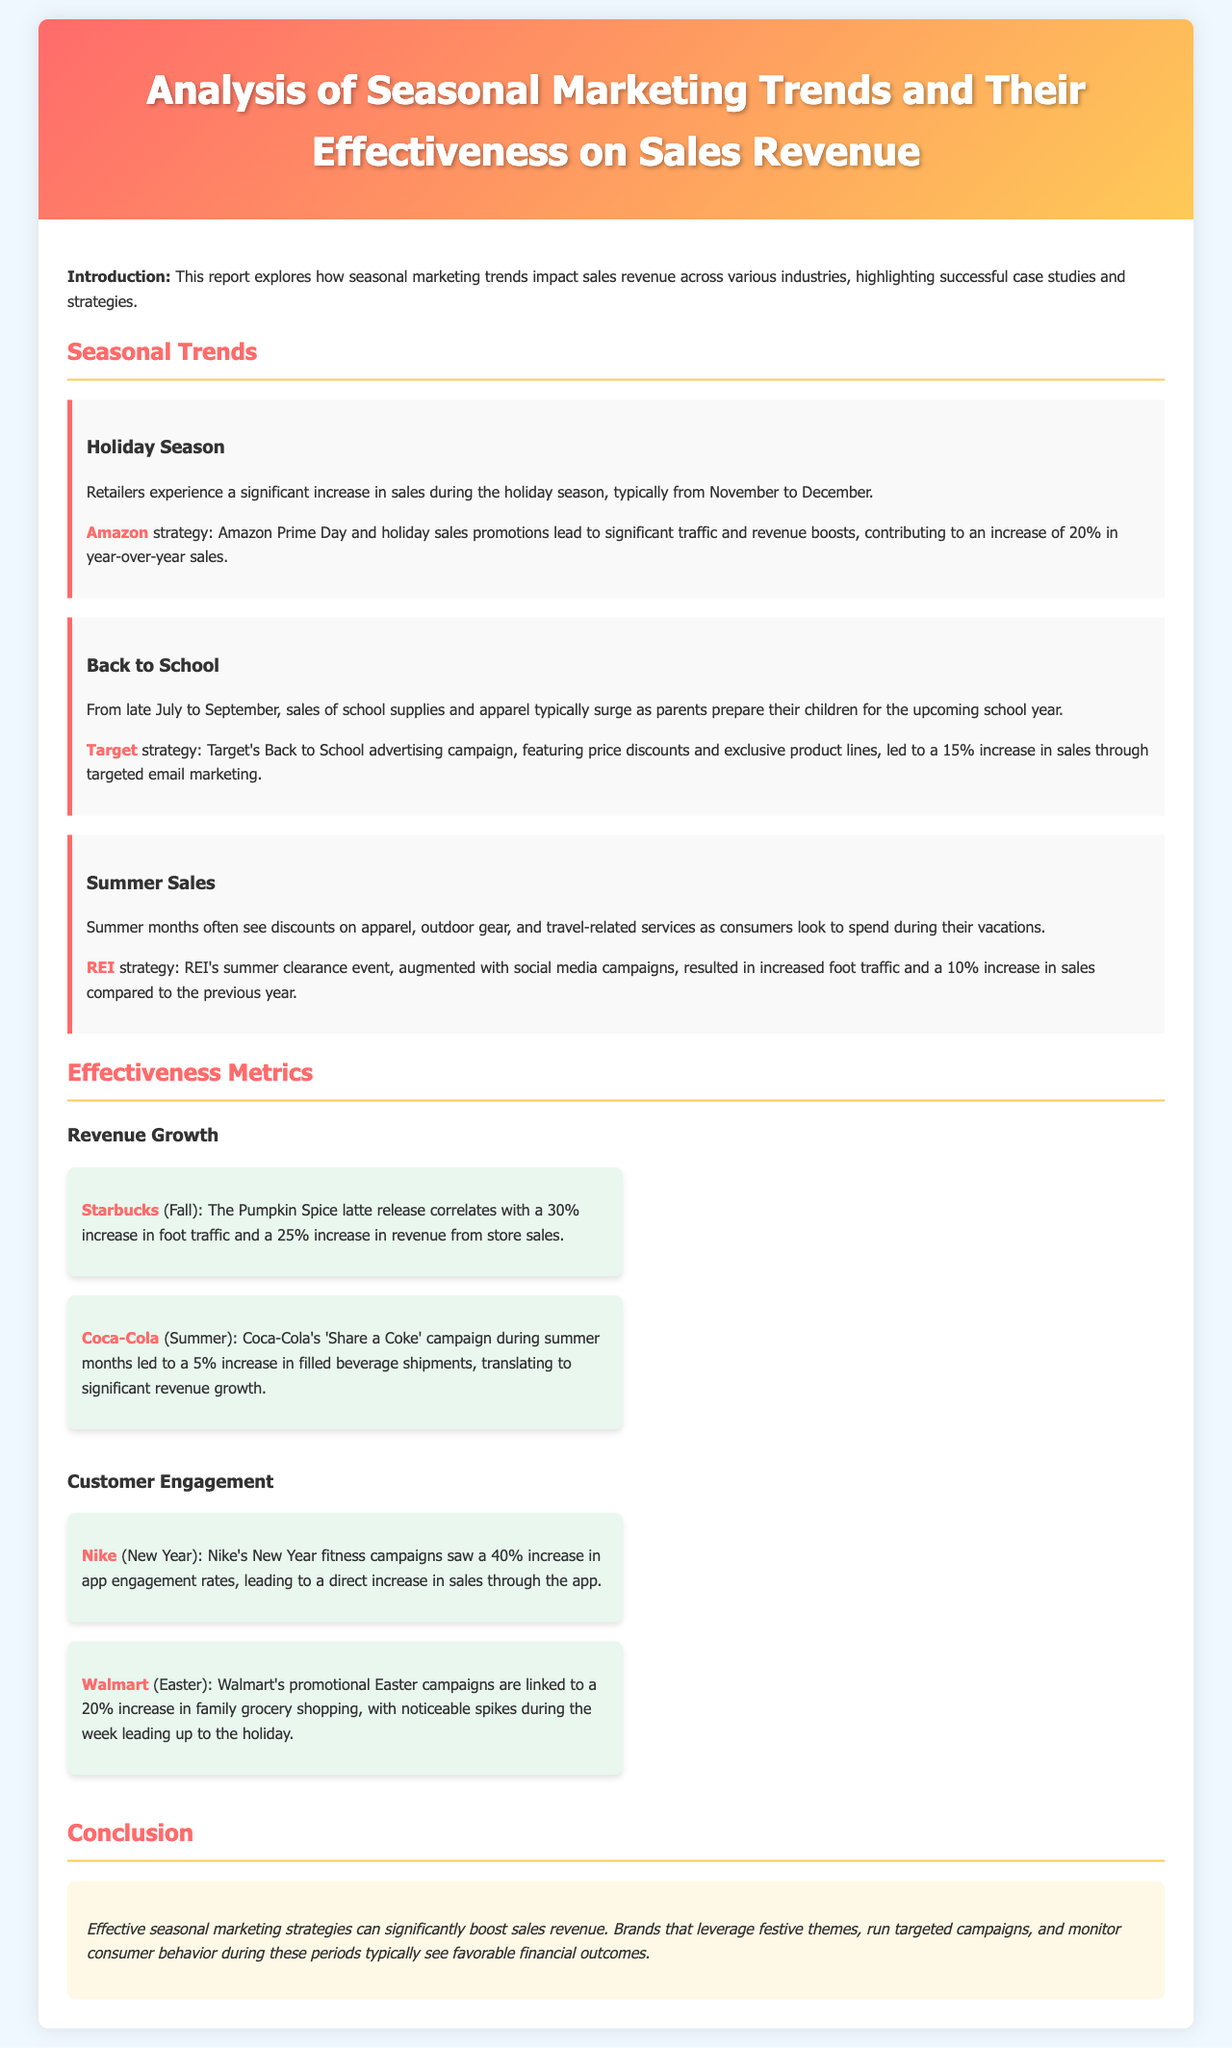What is the main theme of the report? The main theme is how seasonal marketing trends impact sales revenue across various industries.
Answer: seasonal marketing trends During which season does Amazon see a significant increase in sales? The document mentions that Amazon experiences a sales increase during the holiday season, typically from November to December.
Answer: holiday season What percentage increase in sales did Target experience due to its Back to School campaign? Target's Back to School advertising campaign led to a 15% increase in sales.
Answer: 15% Which brand's campaign during fall correlates with a 30% increase in foot traffic? The campaign mentioned is Starbucks' Pumpkin Spice latte release.
Answer: Starbucks What was the increase in customer engagement rates for Nike's New Year campaign? Nike's New Year fitness campaigns saw a 40% increase in app engagement rates.
Answer: 40% Which holiday period does Walmart's promotional campaign link to a 20% increase in grocery shopping? The document states that Walmart sees a spike in family grocery shopping during Easter.
Answer: Easter What strategy led to a 25% increase in revenue for Starbucks? The strategy is the Pumpkin Spice latte release in the fall.
Answer: Pumpkin Spice latte release What effect did Coca-Cola's 'Share a Coke' campaign have on beverage shipments? The campaign led to a 5% increase in filled beverage shipments.
Answer: 5% What is stated as a common outcome of effective seasonal marketing strategies? Effective seasonal marketing strategies typically see favorable financial outcomes.
Answer: favorable financial outcomes 